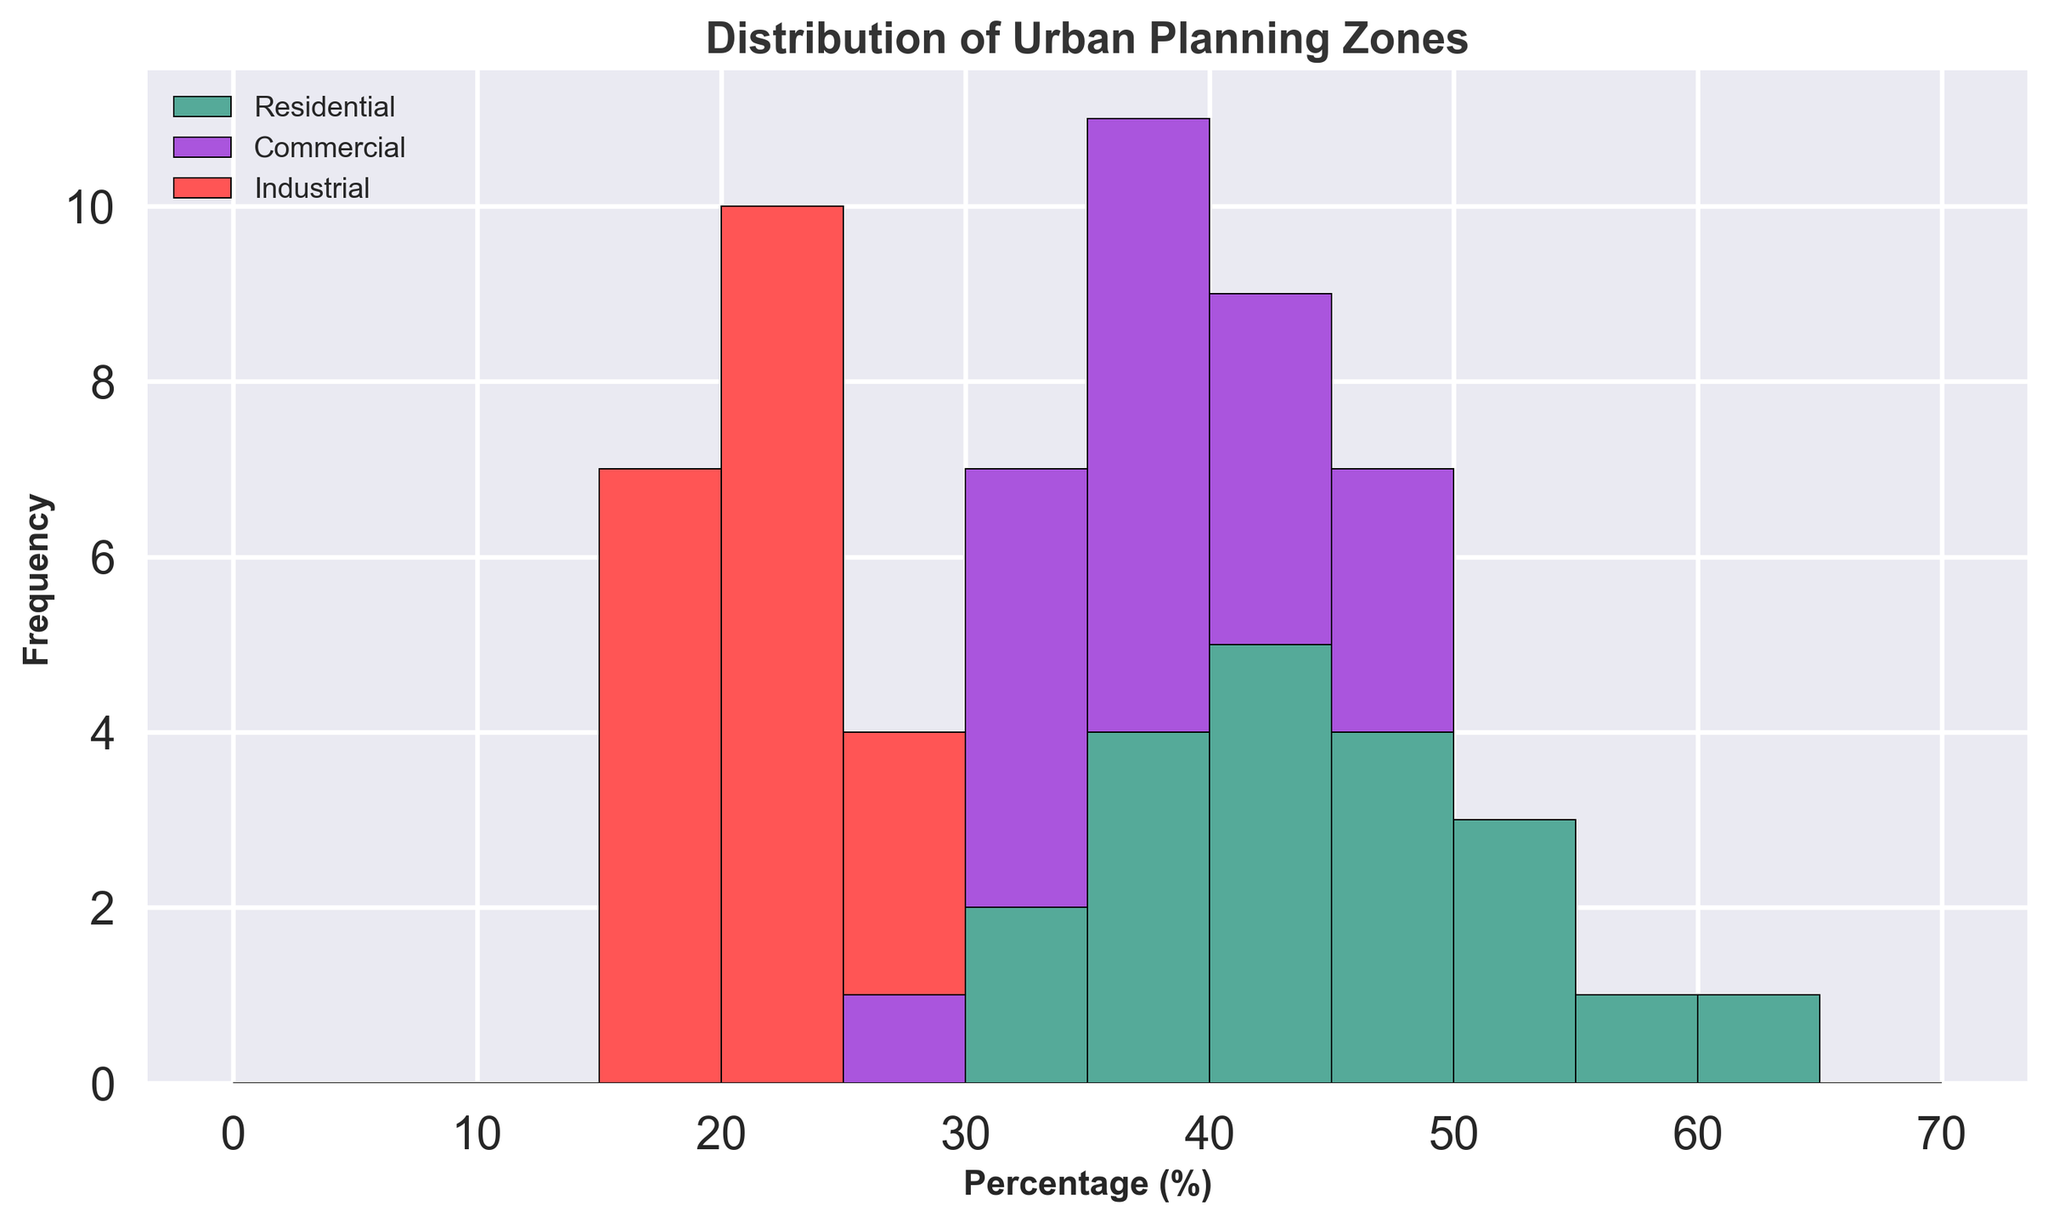What's the range of Residential zone percentages? To find the range of Residential zone percentages, identify the minimum and maximum values in the Residential data set. The minimum value is 30, and the maximum value is 60. The range is found by subtracting the minimum from the maximum, which is 60 - 30 = 30.
Answer: 30 How many times does the Commercial zone percentage fall between 35% and 45%? To find this, count the number of instances in the Commercial data set that fall within the range of 35% to 45%. The values that fit this criterion are: 45, 35, 40, 45, 42, 38, 47, 44, 39, 40, 37. This occurs 11 times.
Answer: 11 Which zone appears the least frequently in the histogram? By observing the histogram, the zone with the smallest frequency can be identified by the shortest cumulative bar height. The Industrial zone, represented in red, consistently appears the least frequently.
Answer: Industrial What is the sum of the frequencies for the Residential and Commercial zones when compared to Industrial zones? First, observe and note the frequency of each of the Residential and Commercial zone bars in the histogram and sum them. Then, do the same for the Industrial zones. Adding up the frequencies for Residential and Commercial and Industrial will show that logistically combined Residential and Commercial zones are greater than the Industrial zone's frequency.
Answer: Residential and Commercial > Industrial Which percentage bin has the highest combined frequency of all zones? To determine this, look for the tallest combined bar height in the histogram, which represents the sum of frequencies of all zones in a particular bin. Based on observation, the 30-35% bin has the highest combined frequency.
Answer: 30-35% What is the average percentage for Residential zones? To find the average, sum all the percentages in the Residential data set and divide by the total number of values. The sum is (30 + 40 + 50 + 60 + 55 + 45 + 50 + 35 + 40 + 38 + 42 + 33 + 36 + 41 + 39 + 44 + 47 + 53 + 49 + 45) = 872. Divide this by 20 (the number of data points), resulting in an average of 43.6.
Answer: 43.6 Which zone's data shows the greatest variation? Variation can be visually identified by how spread out the data is in the histogram. The spread of the Industrial zone data seems the smallest while the Residential data covers a wider range, indicating greater variation. Residential data spans 30% to 60%, indicating greater variation compared to the Commercial and Industrial zones.
Answer: Residential What is the difference between the maximum Commercial zone percentage and the maximum Industrial zone percentage? Locate the maximum percentages for each zone from the data: maximum for Commercial is 47% and for Industrial is 25%. Subtract the maximum Industrial percentage from the maximum Commercial percentage: 47 - 25 = 22.
Answer: 22 Compare the median values of the Residential and Industrial zones. To determine the median, sort the values for each zone and find the middle value. For Residential, the sorted values are 30, 33, 35, 36, 38, 39, 40, 40, 41, 42, 44, 45, 45, 47, 49, 50, 50, 53, 55, 60; the median is (41 + 42)/2 = 41.5. For Industrial, the sorted values are 15, 15, 15, 18, 18, 18, 18, 20, 20, 20, 20, 20, 20, 20, 20, 21, 25, 25, and the median is 20.
Answer: Residential: 41.5, Industrial: 20 